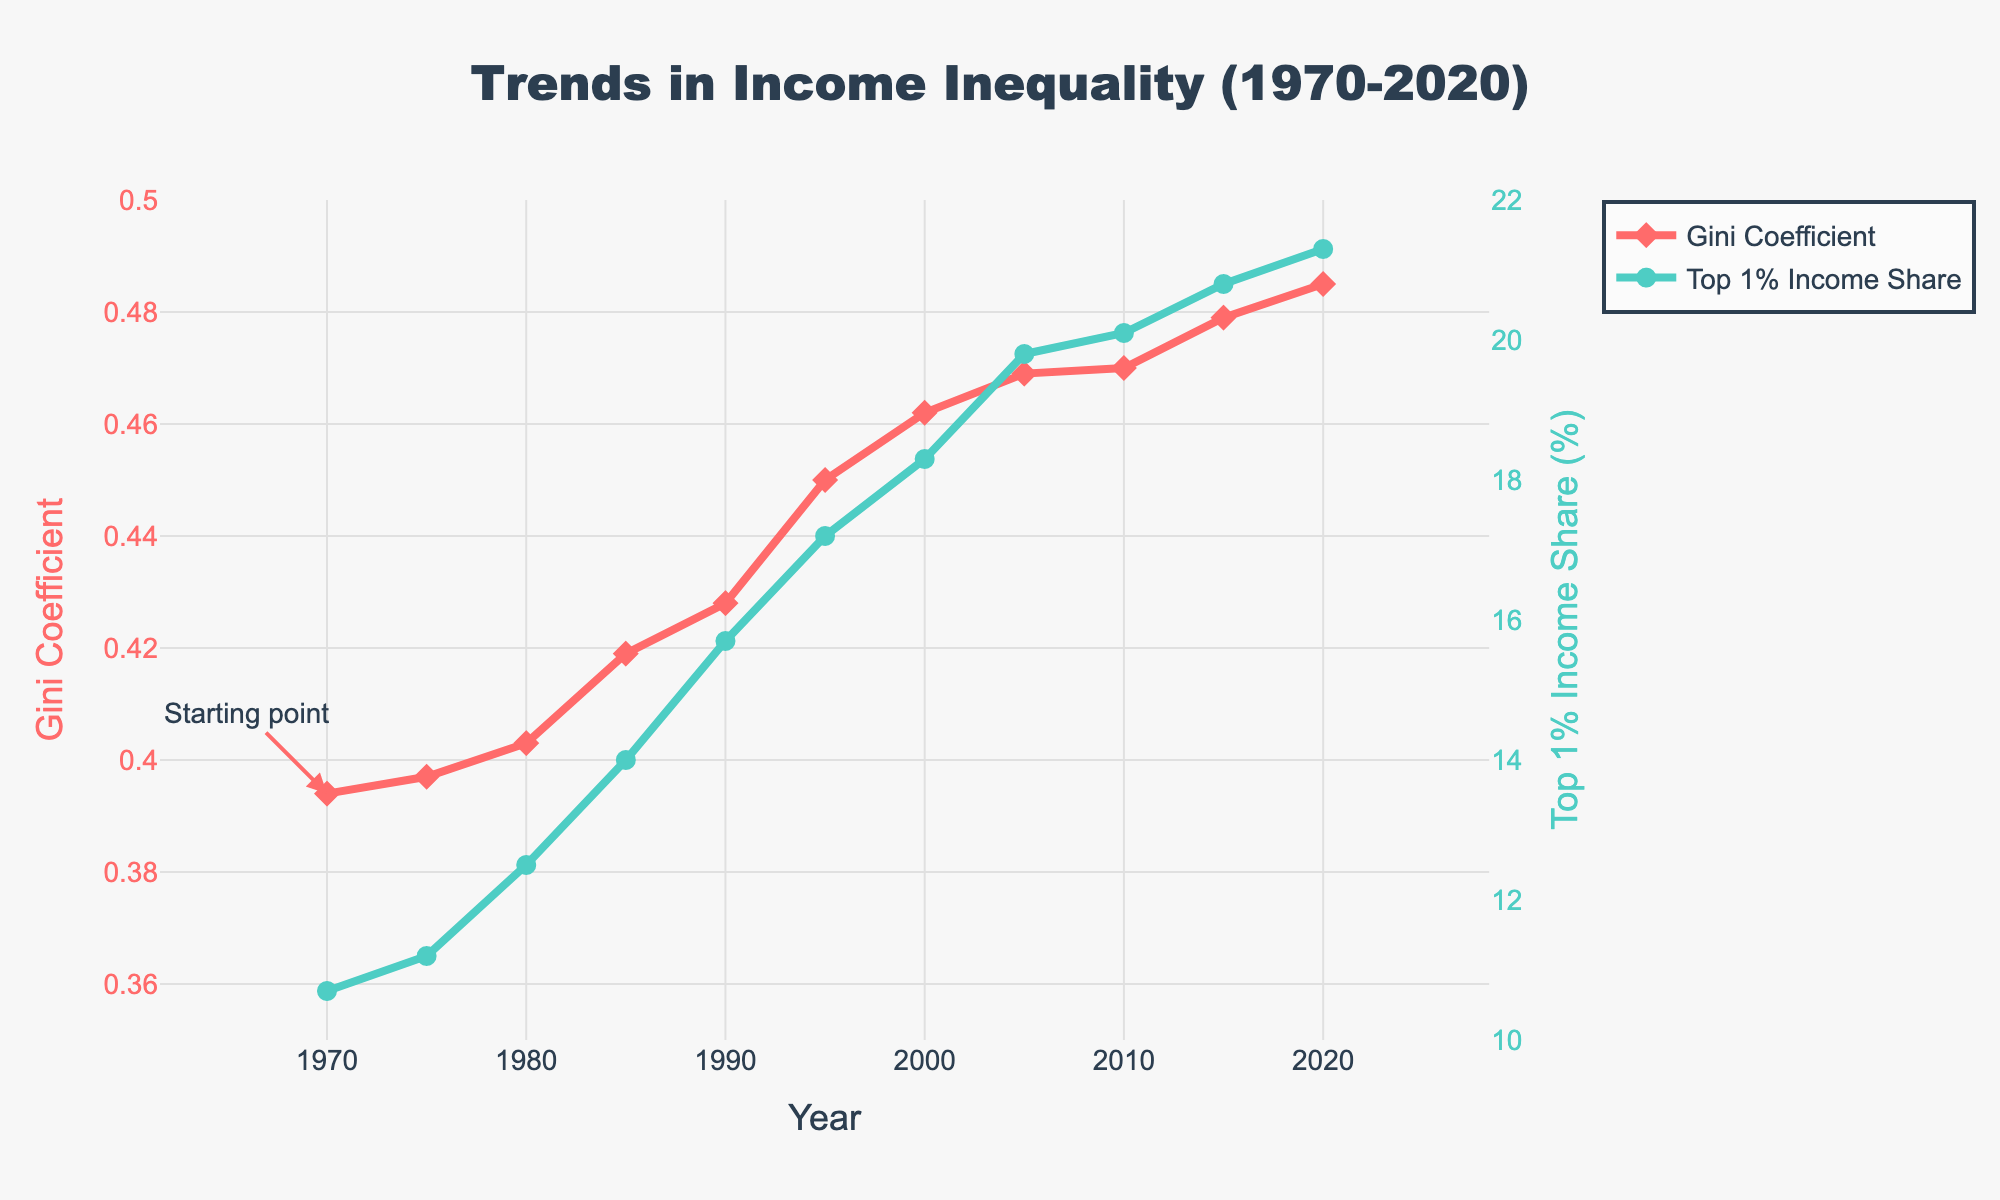What is the Gini Coefficient in 2000? To find the Gini Coefficient, locate the year 2000 on the x-axis and observe the corresponding value on the y-axis. The Gini Coefficient for 2000 is 0.462.
Answer: 0.462 How did the Top 1% Income Share change from 1980 to 2020? Locate the points for 1980 and 2020 on the x-axis and note their corresponding values on the secondary y-axis. In 1980, the Top 1% Income Share was 12.5%, and in 2020, it was 21.3%. The change is 21.3% - 12.5% = 8.8%.
Answer: 8.8% Which year had the highest Gini Coefficient, and what was its value? Look for the peak of the red line (Gini Coefficient) on the figure. The highest value is seen in the year 2020. The corresponding value is 0.485.
Answer: 2020, 0.485 Compare the Gini Coefficient and Top 1% Income Share in 2010. Are they higher or lower than they were in 1990? For 2010, the Gini Coefficient is 0.470, and the Top 1% Income Share is 20.1%. For 1990, the Gini Coefficient is 0.428, and the Top 1% Income Share is 15.7%. Both indicators are higher in 2010 compared to 1990.
Answer: Higher in 2010 What is the increase in Gini Coefficient from 1970 to 2010? The Gini Coefficient in 1970 is 0.394, and in 2010 it is 0.470. The increase is calculated as 0.470 - 0.394 = 0.076.
Answer: 0.076 Between which years did the Gini Coefficient experience the most significant increase? Observe the differences in the Gini Coefficient for each consecutive pair of years. The largest change occurred between 1990 (0.428) and 1995 (0.450).
Answer: 1990 and 1995 Which trace in the chart uses circular markers? Look at the markers used on the graph. The trace with circular markers represents the Top 1% Income Share.
Answer: Top 1% Income Share In which year does the Top 1% Income Share first exceed 20%? Observe the green line representing the Top 1% Income Share. It first exceeds 20% in the year 2010.
Answer: 2010 